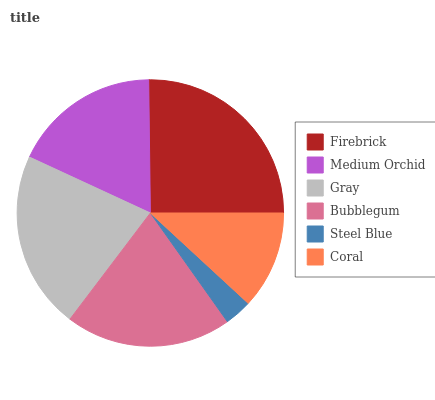Is Steel Blue the minimum?
Answer yes or no. Yes. Is Firebrick the maximum?
Answer yes or no. Yes. Is Medium Orchid the minimum?
Answer yes or no. No. Is Medium Orchid the maximum?
Answer yes or no. No. Is Firebrick greater than Medium Orchid?
Answer yes or no. Yes. Is Medium Orchid less than Firebrick?
Answer yes or no. Yes. Is Medium Orchid greater than Firebrick?
Answer yes or no. No. Is Firebrick less than Medium Orchid?
Answer yes or no. No. Is Bubblegum the high median?
Answer yes or no. Yes. Is Medium Orchid the low median?
Answer yes or no. Yes. Is Gray the high median?
Answer yes or no. No. Is Steel Blue the low median?
Answer yes or no. No. 